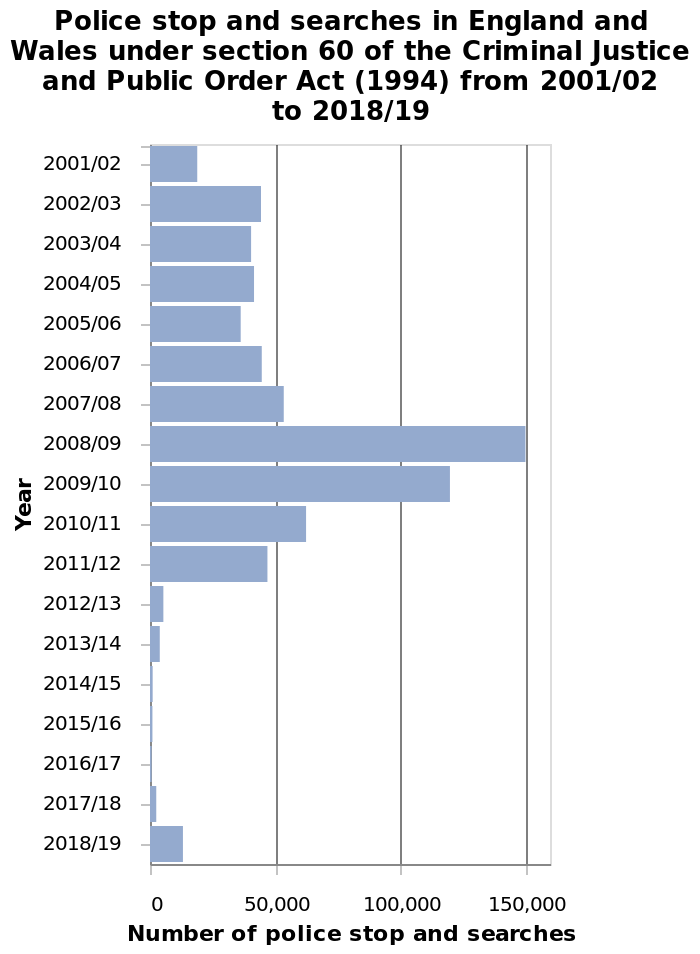<image>
When did the number of police stop and searches peak? The number of police stop and searches peaked during 2008/09. Can you identify a general pattern in the trend of police stop and searches during the mentioned period? Yes, the number of police stop and searches initially peaked in 2008/09, declined over subsequent years, and then experienced a resurgence in 2018/19. Did the number of police stop and searches peak during 2009/08? No.The number of police stop and searches peaked during 2008/09. 